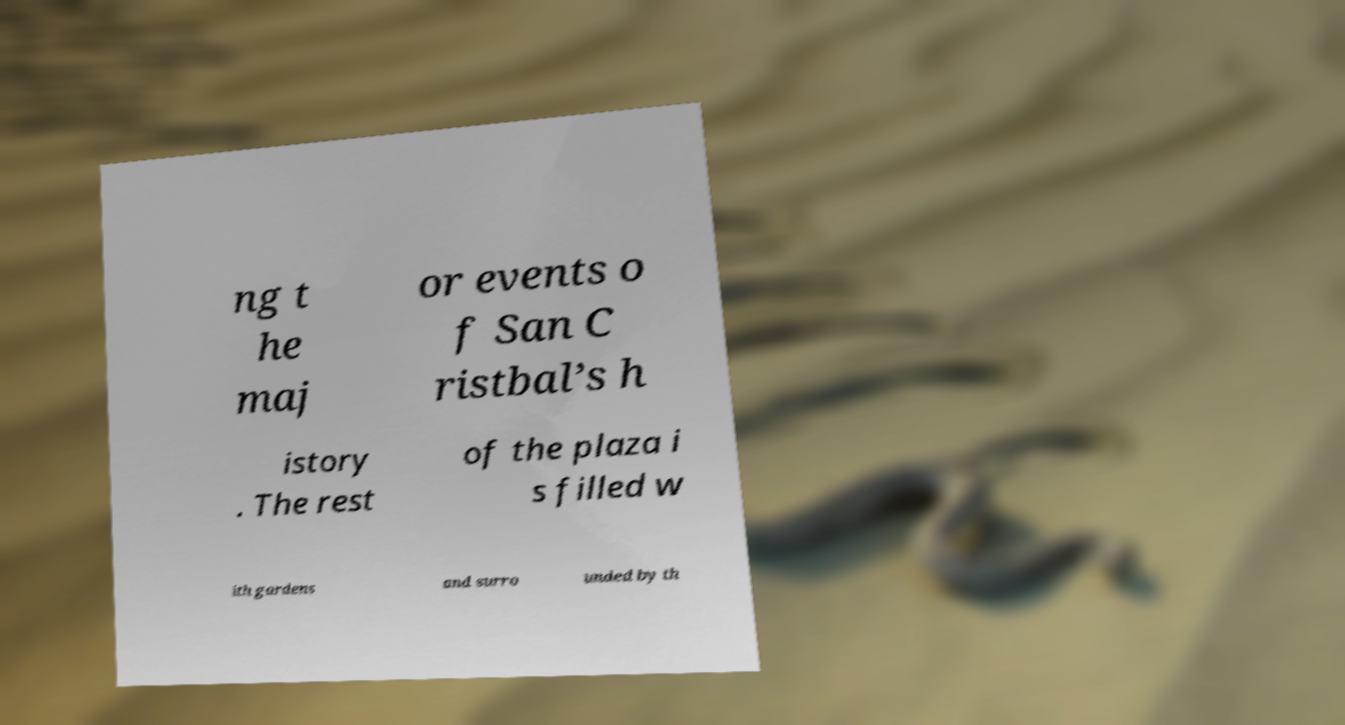I need the written content from this picture converted into text. Can you do that? ng t he maj or events o f San C ristbal’s h istory . The rest of the plaza i s filled w ith gardens and surro unded by th 